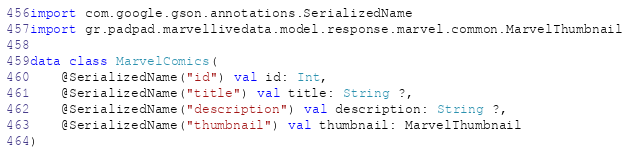Convert code to text. <code><loc_0><loc_0><loc_500><loc_500><_Kotlin_>import com.google.gson.annotations.SerializedName
import gr.padpad.marvellivedata.model.response.marvel.common.MarvelThumbnail

data class MarvelComics(
    @SerializedName("id") val id: Int,
    @SerializedName("title") val title: String ?,
    @SerializedName("description") val description: String ?,
    @SerializedName("thumbnail") val thumbnail: MarvelThumbnail
)</code> 